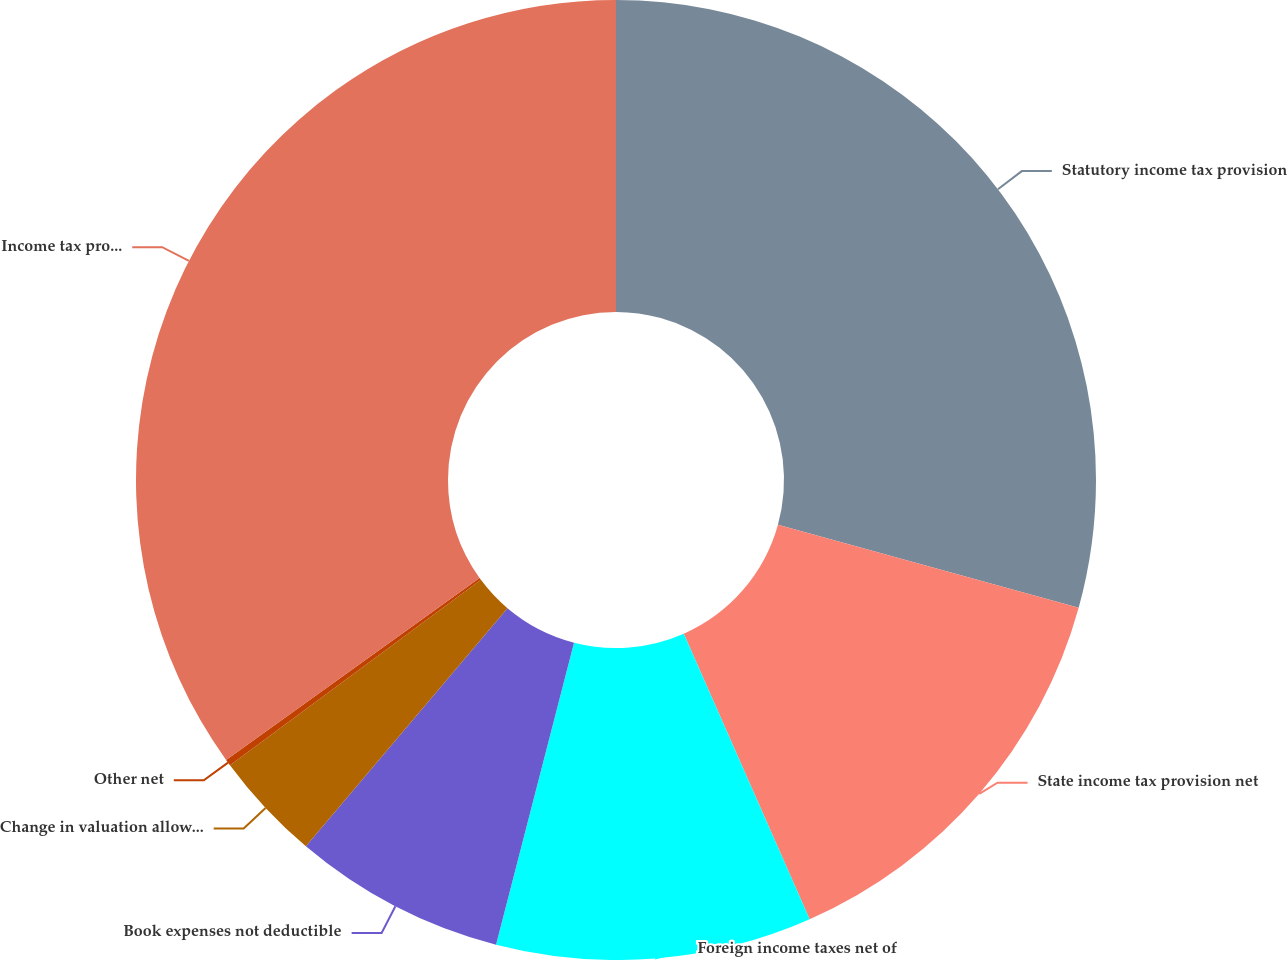Convert chart. <chart><loc_0><loc_0><loc_500><loc_500><pie_chart><fcel>Statutory income tax provision<fcel>State income tax provision net<fcel>Foreign income taxes net of<fcel>Book expenses not deductible<fcel>Change in valuation allowance<fcel>Other net<fcel>Income tax provision<nl><fcel>29.29%<fcel>14.1%<fcel>10.63%<fcel>7.16%<fcel>3.69%<fcel>0.22%<fcel>34.91%<nl></chart> 